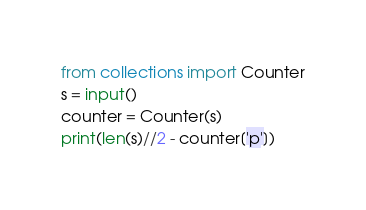<code> <loc_0><loc_0><loc_500><loc_500><_Python_>from collections import Counter
s = input()
counter = Counter(s)
print(len(s)//2 - counter['p'])</code> 